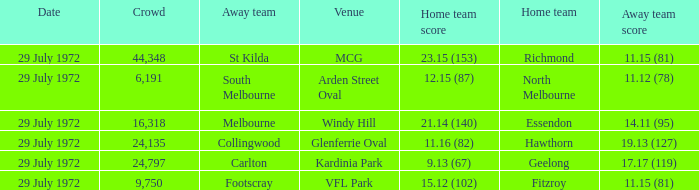What was the largest crowd size at arden street oval? 6191.0. 